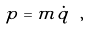<formula> <loc_0><loc_0><loc_500><loc_500>p = m \dot { q } \ ,</formula> 